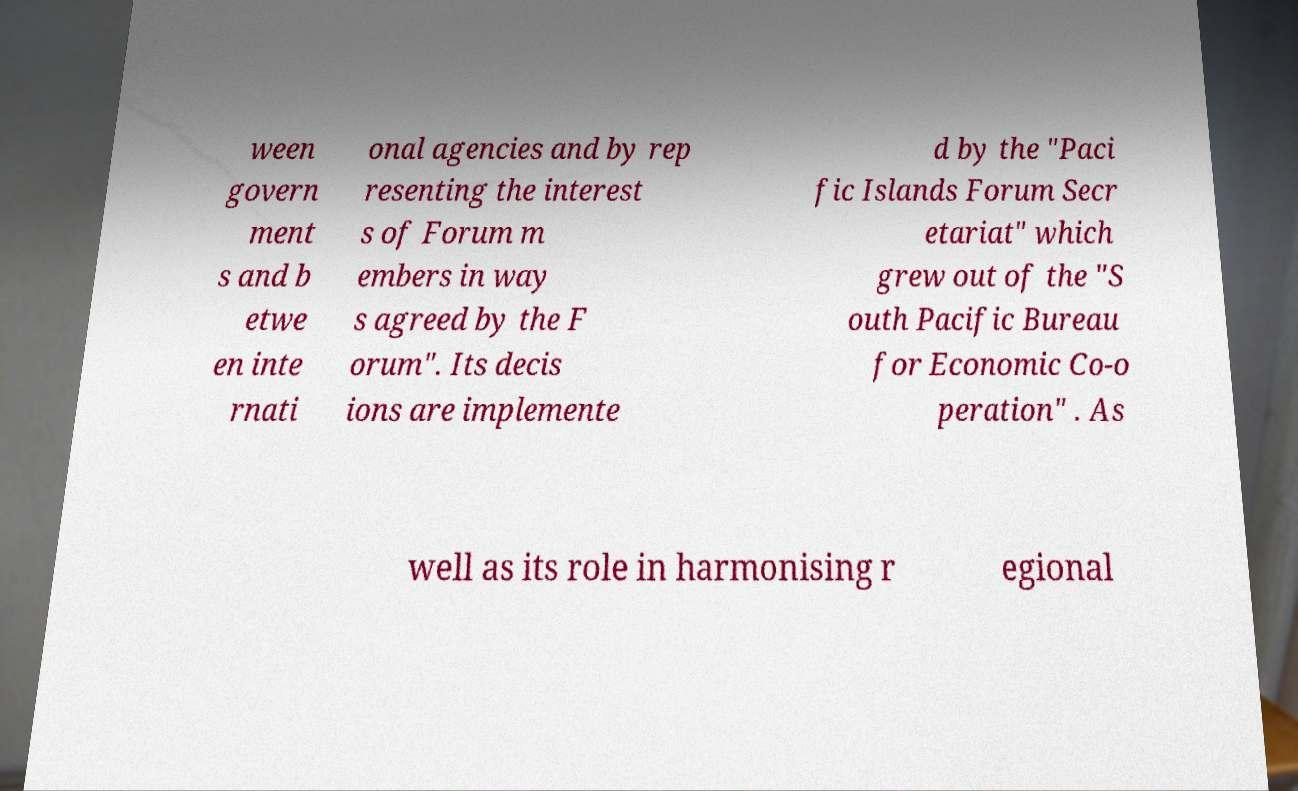Please read and relay the text visible in this image. What does it say? ween govern ment s and b etwe en inte rnati onal agencies and by rep resenting the interest s of Forum m embers in way s agreed by the F orum". Its decis ions are implemente d by the "Paci fic Islands Forum Secr etariat" which grew out of the "S outh Pacific Bureau for Economic Co-o peration" . As well as its role in harmonising r egional 